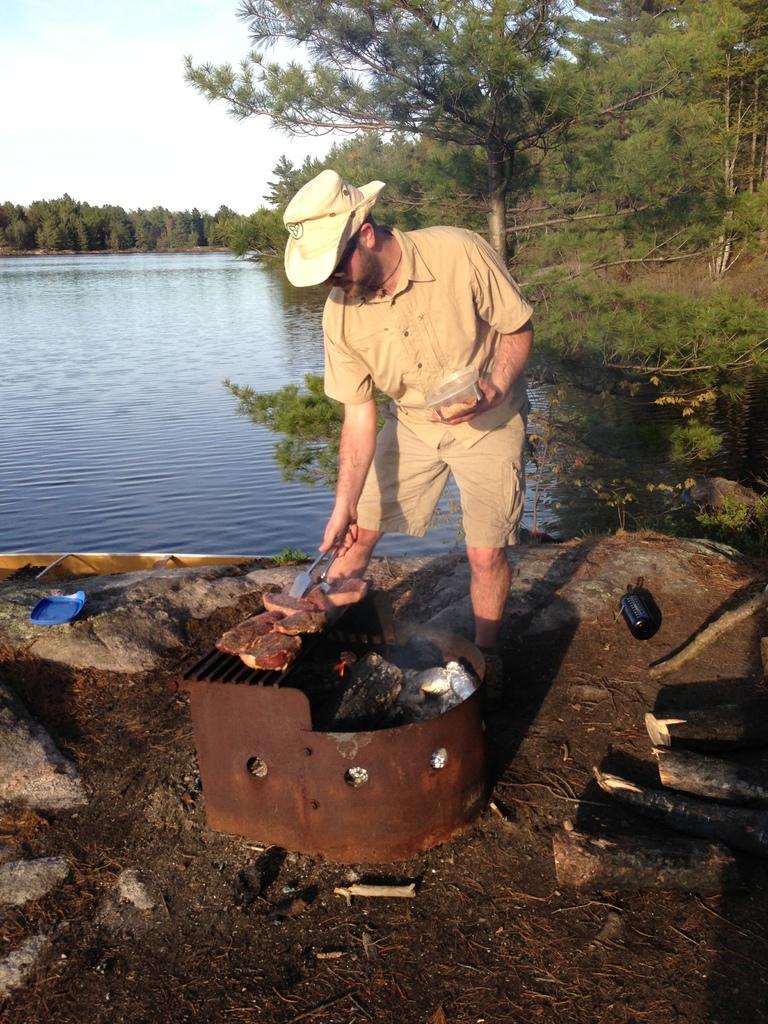How would you summarize this image in a sentence or two? In this picture there is a man who is standing in the center of the image he is grilling and there are trees and water in the background area of the image, there are logs on the right side of the image and there is a boat on the left side of the image. 